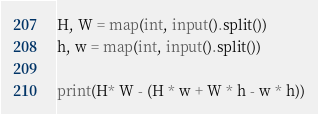Convert code to text. <code><loc_0><loc_0><loc_500><loc_500><_Python_>H, W = map(int, input().split())
h, w = map(int, input().split())

print(H* W - (H * w + W * h - w * h))</code> 